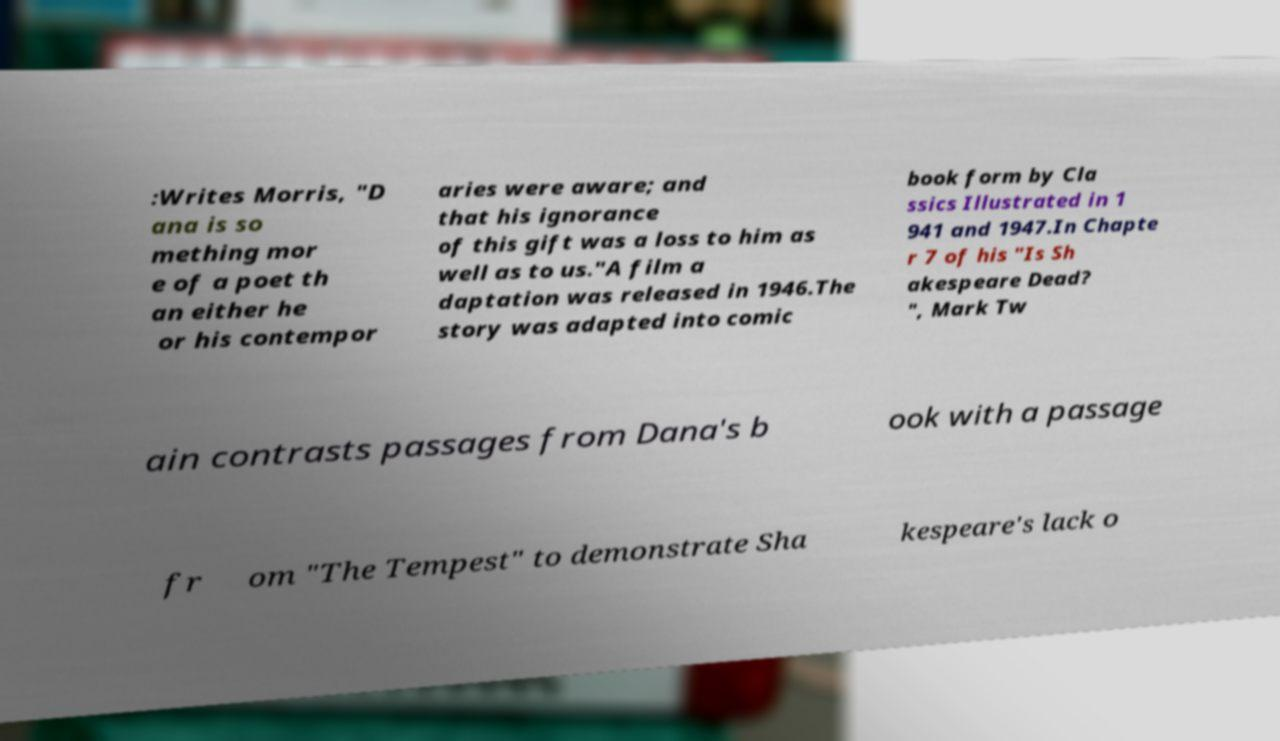What messages or text are displayed in this image? I need them in a readable, typed format. :Writes Morris, "D ana is so mething mor e of a poet th an either he or his contempor aries were aware; and that his ignorance of this gift was a loss to him as well as to us."A film a daptation was released in 1946.The story was adapted into comic book form by Cla ssics Illustrated in 1 941 and 1947.In Chapte r 7 of his "Is Sh akespeare Dead? ", Mark Tw ain contrasts passages from Dana's b ook with a passage fr om "The Tempest" to demonstrate Sha kespeare's lack o 